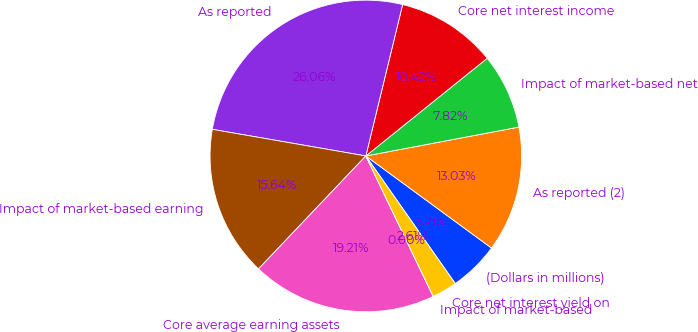<chart> <loc_0><loc_0><loc_500><loc_500><pie_chart><fcel>(Dollars in millions)<fcel>As reported (2)<fcel>Impact of market-based net<fcel>Core net interest income<fcel>As reported<fcel>Impact of market-based earning<fcel>Core average earning assets<fcel>Impact of market-based<fcel>Core net interest yield on<nl><fcel>5.21%<fcel>13.03%<fcel>7.82%<fcel>10.42%<fcel>26.06%<fcel>15.64%<fcel>19.21%<fcel>0.0%<fcel>2.61%<nl></chart> 